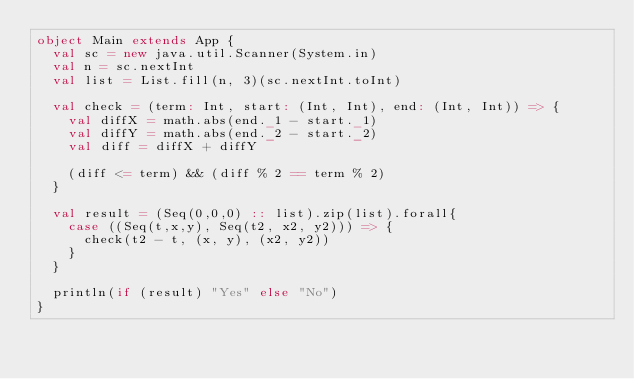Convert code to text. <code><loc_0><loc_0><loc_500><loc_500><_Scala_>object Main extends App {
  val sc = new java.util.Scanner(System.in)
  val n = sc.nextInt
  val list = List.fill(n, 3)(sc.nextInt.toInt)
    
  val check = (term: Int, start: (Int, Int), end: (Int, Int)) => {
    val diffX = math.abs(end._1 - start._1)
    val diffY = math.abs(end._2 - start._2)
    val diff = diffX + diffY
    
    (diff <= term) && (diff % 2 == term % 2)
  }
  
  val result = (Seq(0,0,0) :: list).zip(list).forall{
    case ((Seq(t,x,y), Seq(t2, x2, y2))) => {
  	  check(t2 - t, (x, y), (x2, y2))
  	}
  }
  
  println(if (result) "Yes" else "No")
}</code> 